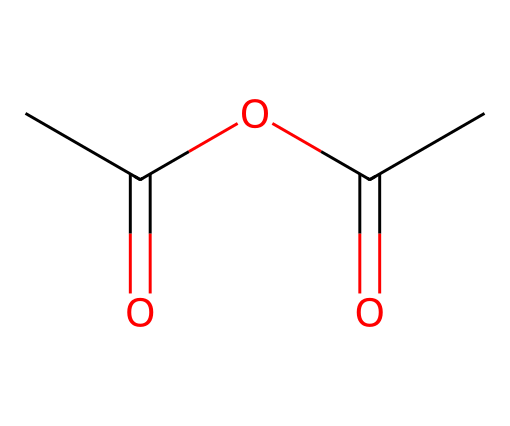how many carbon atoms are present in acetic anhydride? By analyzing the SMILES structure, we observe that there are three "C" characters, indicating the presence of three carbon atoms in the molecular structure.
Answer: three what type of functional groups are present in acetic anhydride? The structure indicates the presence of two acyl groups connected by an oxygen atom, classifying the functional groups as anhydride groups derived from acetic acid.
Answer: anhydride groups how many total oxygen atoms are in acetic anhydride? In the SMILES representation, we see two "O" characters, meaning there are two oxygen atoms present in the compound.
Answer: two which type of compound is acetic anhydride classified as? Acetic anhydride is classified as an acid anhydride, which is evident from its structure that shows a combination of acetic acid residues losing water.
Answer: acid anhydride what is the molecular formula for acetic anhydride? To derive the molecular formula, we count the elements: three carbon atoms, four hydrogen atoms, and two oxygen atoms, leading to the formula C4H6O3.
Answer: C4H6O3 what is the total number of bonds in acetic anhydride? In the structure, there are five single bonds and one double bond connecting the atoms, leading to a total of six bonds in the molecule.
Answer: six how does the structure of acetic anhydride influence its reactivity? The presence of the acyl functional groups in the anhydride shows that acetic anhydride can easily react with nucleophiles due to the polarized carbonyl carbons, enhancing its reactivity.
Answer: enhances reactivity 